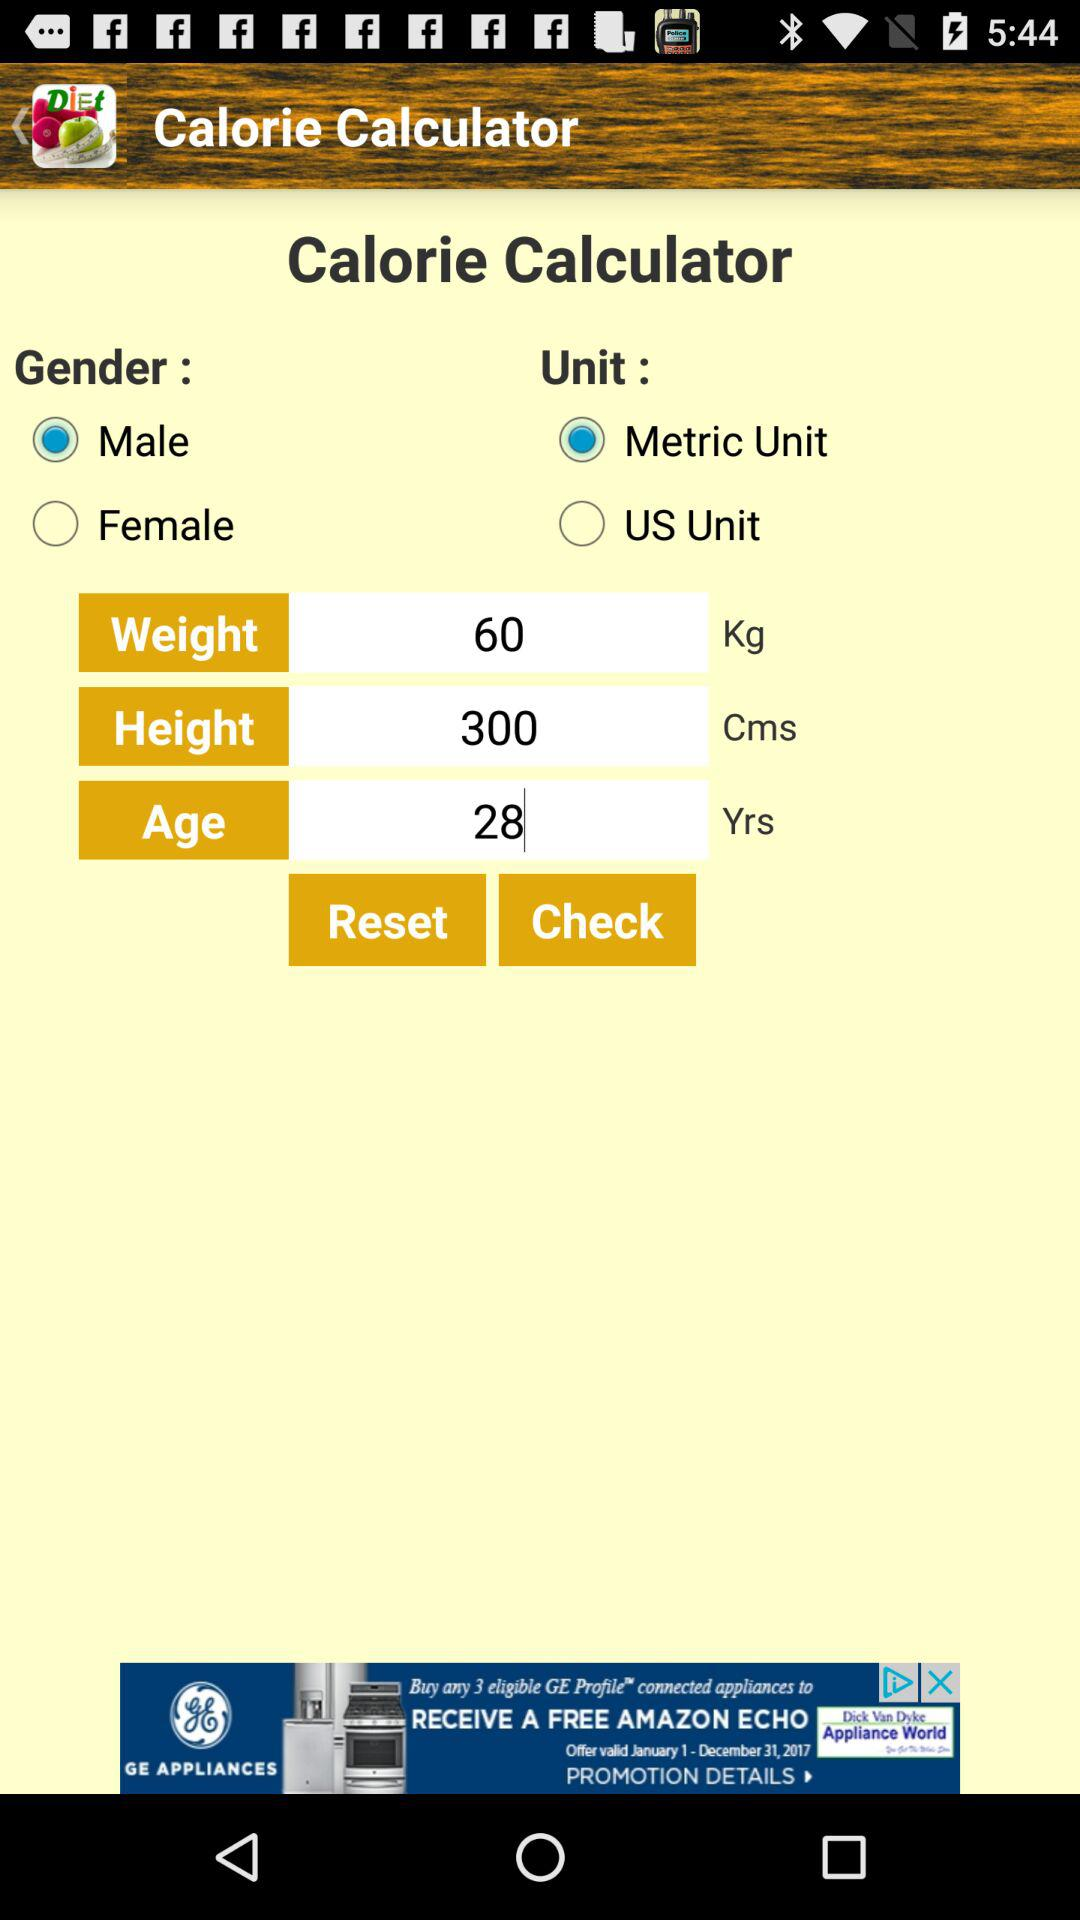What is the given height? The given height is 300 centimeters. 